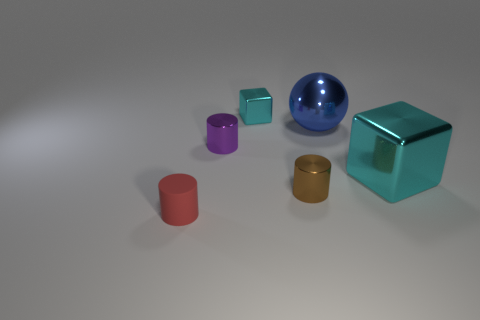Add 2 yellow matte cubes. How many objects exist? 8 Subtract all balls. How many objects are left? 5 Add 4 small purple cylinders. How many small purple cylinders are left? 5 Add 3 small blue spheres. How many small blue spheres exist? 3 Subtract 0 yellow cylinders. How many objects are left? 6 Subtract all brown shiny cylinders. Subtract all cylinders. How many objects are left? 2 